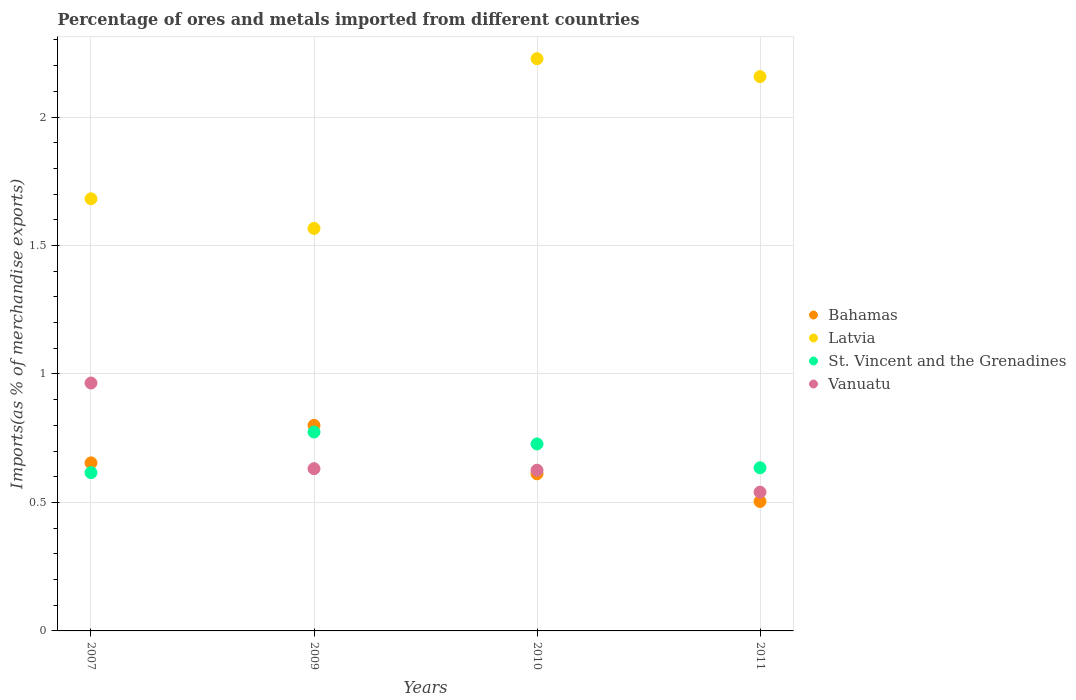Is the number of dotlines equal to the number of legend labels?
Offer a terse response. Yes. What is the percentage of imports to different countries in Vanuatu in 2011?
Make the answer very short. 0.54. Across all years, what is the maximum percentage of imports to different countries in St. Vincent and the Grenadines?
Provide a succinct answer. 0.77. Across all years, what is the minimum percentage of imports to different countries in Vanuatu?
Keep it short and to the point. 0.54. In which year was the percentage of imports to different countries in Vanuatu minimum?
Your answer should be very brief. 2011. What is the total percentage of imports to different countries in Vanuatu in the graph?
Give a very brief answer. 2.76. What is the difference between the percentage of imports to different countries in St. Vincent and the Grenadines in 2010 and that in 2011?
Offer a terse response. 0.09. What is the difference between the percentage of imports to different countries in St. Vincent and the Grenadines in 2010 and the percentage of imports to different countries in Latvia in 2009?
Your answer should be compact. -0.84. What is the average percentage of imports to different countries in Latvia per year?
Provide a short and direct response. 1.91. In the year 2009, what is the difference between the percentage of imports to different countries in Vanuatu and percentage of imports to different countries in Bahamas?
Provide a short and direct response. -0.17. What is the ratio of the percentage of imports to different countries in Vanuatu in 2010 to that in 2011?
Your answer should be very brief. 1.16. Is the difference between the percentage of imports to different countries in Vanuatu in 2009 and 2010 greater than the difference between the percentage of imports to different countries in Bahamas in 2009 and 2010?
Your response must be concise. No. What is the difference between the highest and the second highest percentage of imports to different countries in Vanuatu?
Ensure brevity in your answer.  0.33. What is the difference between the highest and the lowest percentage of imports to different countries in Latvia?
Make the answer very short. 0.66. In how many years, is the percentage of imports to different countries in Bahamas greater than the average percentage of imports to different countries in Bahamas taken over all years?
Ensure brevity in your answer.  2. Is it the case that in every year, the sum of the percentage of imports to different countries in Latvia and percentage of imports to different countries in Bahamas  is greater than the percentage of imports to different countries in St. Vincent and the Grenadines?
Your response must be concise. Yes. Does the percentage of imports to different countries in St. Vincent and the Grenadines monotonically increase over the years?
Make the answer very short. No. Is the percentage of imports to different countries in Vanuatu strictly greater than the percentage of imports to different countries in Latvia over the years?
Your response must be concise. No. Is the percentage of imports to different countries in Vanuatu strictly less than the percentage of imports to different countries in Bahamas over the years?
Offer a terse response. No. How many years are there in the graph?
Keep it short and to the point. 4. Does the graph contain grids?
Your response must be concise. Yes. How many legend labels are there?
Make the answer very short. 4. How are the legend labels stacked?
Give a very brief answer. Vertical. What is the title of the graph?
Offer a terse response. Percentage of ores and metals imported from different countries. Does "Northern Mariana Islands" appear as one of the legend labels in the graph?
Make the answer very short. No. What is the label or title of the Y-axis?
Give a very brief answer. Imports(as % of merchandise exports). What is the Imports(as % of merchandise exports) of Bahamas in 2007?
Ensure brevity in your answer.  0.65. What is the Imports(as % of merchandise exports) in Latvia in 2007?
Provide a short and direct response. 1.68. What is the Imports(as % of merchandise exports) in St. Vincent and the Grenadines in 2007?
Your answer should be compact. 0.62. What is the Imports(as % of merchandise exports) of Vanuatu in 2007?
Offer a very short reply. 0.96. What is the Imports(as % of merchandise exports) of Bahamas in 2009?
Your answer should be compact. 0.8. What is the Imports(as % of merchandise exports) in Latvia in 2009?
Make the answer very short. 1.57. What is the Imports(as % of merchandise exports) in St. Vincent and the Grenadines in 2009?
Offer a terse response. 0.77. What is the Imports(as % of merchandise exports) in Vanuatu in 2009?
Provide a short and direct response. 0.63. What is the Imports(as % of merchandise exports) of Bahamas in 2010?
Offer a terse response. 0.61. What is the Imports(as % of merchandise exports) of Latvia in 2010?
Make the answer very short. 2.23. What is the Imports(as % of merchandise exports) in St. Vincent and the Grenadines in 2010?
Your answer should be very brief. 0.73. What is the Imports(as % of merchandise exports) in Vanuatu in 2010?
Your answer should be compact. 0.63. What is the Imports(as % of merchandise exports) in Bahamas in 2011?
Offer a terse response. 0.5. What is the Imports(as % of merchandise exports) of Latvia in 2011?
Offer a very short reply. 2.16. What is the Imports(as % of merchandise exports) of St. Vincent and the Grenadines in 2011?
Your response must be concise. 0.64. What is the Imports(as % of merchandise exports) of Vanuatu in 2011?
Your answer should be very brief. 0.54. Across all years, what is the maximum Imports(as % of merchandise exports) in Bahamas?
Make the answer very short. 0.8. Across all years, what is the maximum Imports(as % of merchandise exports) in Latvia?
Make the answer very short. 2.23. Across all years, what is the maximum Imports(as % of merchandise exports) of St. Vincent and the Grenadines?
Your response must be concise. 0.77. Across all years, what is the maximum Imports(as % of merchandise exports) of Vanuatu?
Offer a very short reply. 0.96. Across all years, what is the minimum Imports(as % of merchandise exports) of Bahamas?
Offer a terse response. 0.5. Across all years, what is the minimum Imports(as % of merchandise exports) in Latvia?
Offer a very short reply. 1.57. Across all years, what is the minimum Imports(as % of merchandise exports) in St. Vincent and the Grenadines?
Keep it short and to the point. 0.62. Across all years, what is the minimum Imports(as % of merchandise exports) of Vanuatu?
Provide a succinct answer. 0.54. What is the total Imports(as % of merchandise exports) in Bahamas in the graph?
Give a very brief answer. 2.57. What is the total Imports(as % of merchandise exports) of Latvia in the graph?
Your answer should be compact. 7.63. What is the total Imports(as % of merchandise exports) in St. Vincent and the Grenadines in the graph?
Your answer should be compact. 2.75. What is the total Imports(as % of merchandise exports) in Vanuatu in the graph?
Your answer should be very brief. 2.76. What is the difference between the Imports(as % of merchandise exports) in Bahamas in 2007 and that in 2009?
Provide a succinct answer. -0.15. What is the difference between the Imports(as % of merchandise exports) of Latvia in 2007 and that in 2009?
Your answer should be very brief. 0.12. What is the difference between the Imports(as % of merchandise exports) in St. Vincent and the Grenadines in 2007 and that in 2009?
Provide a succinct answer. -0.16. What is the difference between the Imports(as % of merchandise exports) of Vanuatu in 2007 and that in 2009?
Your response must be concise. 0.33. What is the difference between the Imports(as % of merchandise exports) in Bahamas in 2007 and that in 2010?
Your answer should be compact. 0.04. What is the difference between the Imports(as % of merchandise exports) in Latvia in 2007 and that in 2010?
Provide a short and direct response. -0.55. What is the difference between the Imports(as % of merchandise exports) of St. Vincent and the Grenadines in 2007 and that in 2010?
Your answer should be compact. -0.11. What is the difference between the Imports(as % of merchandise exports) in Vanuatu in 2007 and that in 2010?
Make the answer very short. 0.34. What is the difference between the Imports(as % of merchandise exports) of Bahamas in 2007 and that in 2011?
Provide a succinct answer. 0.15. What is the difference between the Imports(as % of merchandise exports) of Latvia in 2007 and that in 2011?
Offer a terse response. -0.48. What is the difference between the Imports(as % of merchandise exports) of St. Vincent and the Grenadines in 2007 and that in 2011?
Your response must be concise. -0.02. What is the difference between the Imports(as % of merchandise exports) in Vanuatu in 2007 and that in 2011?
Your answer should be compact. 0.42. What is the difference between the Imports(as % of merchandise exports) in Bahamas in 2009 and that in 2010?
Make the answer very short. 0.19. What is the difference between the Imports(as % of merchandise exports) in Latvia in 2009 and that in 2010?
Your response must be concise. -0.66. What is the difference between the Imports(as % of merchandise exports) in St. Vincent and the Grenadines in 2009 and that in 2010?
Offer a terse response. 0.05. What is the difference between the Imports(as % of merchandise exports) of Vanuatu in 2009 and that in 2010?
Make the answer very short. 0.01. What is the difference between the Imports(as % of merchandise exports) in Bahamas in 2009 and that in 2011?
Give a very brief answer. 0.3. What is the difference between the Imports(as % of merchandise exports) in Latvia in 2009 and that in 2011?
Make the answer very short. -0.59. What is the difference between the Imports(as % of merchandise exports) in St. Vincent and the Grenadines in 2009 and that in 2011?
Ensure brevity in your answer.  0.14. What is the difference between the Imports(as % of merchandise exports) of Vanuatu in 2009 and that in 2011?
Keep it short and to the point. 0.09. What is the difference between the Imports(as % of merchandise exports) in Bahamas in 2010 and that in 2011?
Your answer should be compact. 0.11. What is the difference between the Imports(as % of merchandise exports) of Latvia in 2010 and that in 2011?
Provide a succinct answer. 0.07. What is the difference between the Imports(as % of merchandise exports) of St. Vincent and the Grenadines in 2010 and that in 2011?
Offer a very short reply. 0.09. What is the difference between the Imports(as % of merchandise exports) in Vanuatu in 2010 and that in 2011?
Offer a terse response. 0.09. What is the difference between the Imports(as % of merchandise exports) in Bahamas in 2007 and the Imports(as % of merchandise exports) in Latvia in 2009?
Keep it short and to the point. -0.91. What is the difference between the Imports(as % of merchandise exports) of Bahamas in 2007 and the Imports(as % of merchandise exports) of St. Vincent and the Grenadines in 2009?
Your answer should be compact. -0.12. What is the difference between the Imports(as % of merchandise exports) of Bahamas in 2007 and the Imports(as % of merchandise exports) of Vanuatu in 2009?
Provide a short and direct response. 0.02. What is the difference between the Imports(as % of merchandise exports) in Latvia in 2007 and the Imports(as % of merchandise exports) in St. Vincent and the Grenadines in 2009?
Your answer should be very brief. 0.91. What is the difference between the Imports(as % of merchandise exports) of Latvia in 2007 and the Imports(as % of merchandise exports) of Vanuatu in 2009?
Offer a very short reply. 1.05. What is the difference between the Imports(as % of merchandise exports) in St. Vincent and the Grenadines in 2007 and the Imports(as % of merchandise exports) in Vanuatu in 2009?
Ensure brevity in your answer.  -0.02. What is the difference between the Imports(as % of merchandise exports) of Bahamas in 2007 and the Imports(as % of merchandise exports) of Latvia in 2010?
Offer a terse response. -1.57. What is the difference between the Imports(as % of merchandise exports) in Bahamas in 2007 and the Imports(as % of merchandise exports) in St. Vincent and the Grenadines in 2010?
Your answer should be very brief. -0.07. What is the difference between the Imports(as % of merchandise exports) in Bahamas in 2007 and the Imports(as % of merchandise exports) in Vanuatu in 2010?
Your answer should be compact. 0.03. What is the difference between the Imports(as % of merchandise exports) of Latvia in 2007 and the Imports(as % of merchandise exports) of St. Vincent and the Grenadines in 2010?
Keep it short and to the point. 0.95. What is the difference between the Imports(as % of merchandise exports) of Latvia in 2007 and the Imports(as % of merchandise exports) of Vanuatu in 2010?
Your answer should be very brief. 1.06. What is the difference between the Imports(as % of merchandise exports) of St. Vincent and the Grenadines in 2007 and the Imports(as % of merchandise exports) of Vanuatu in 2010?
Offer a terse response. -0.01. What is the difference between the Imports(as % of merchandise exports) of Bahamas in 2007 and the Imports(as % of merchandise exports) of Latvia in 2011?
Keep it short and to the point. -1.5. What is the difference between the Imports(as % of merchandise exports) of Bahamas in 2007 and the Imports(as % of merchandise exports) of St. Vincent and the Grenadines in 2011?
Your answer should be compact. 0.02. What is the difference between the Imports(as % of merchandise exports) of Bahamas in 2007 and the Imports(as % of merchandise exports) of Vanuatu in 2011?
Keep it short and to the point. 0.11. What is the difference between the Imports(as % of merchandise exports) of Latvia in 2007 and the Imports(as % of merchandise exports) of St. Vincent and the Grenadines in 2011?
Ensure brevity in your answer.  1.05. What is the difference between the Imports(as % of merchandise exports) of Latvia in 2007 and the Imports(as % of merchandise exports) of Vanuatu in 2011?
Ensure brevity in your answer.  1.14. What is the difference between the Imports(as % of merchandise exports) in St. Vincent and the Grenadines in 2007 and the Imports(as % of merchandise exports) in Vanuatu in 2011?
Keep it short and to the point. 0.08. What is the difference between the Imports(as % of merchandise exports) of Bahamas in 2009 and the Imports(as % of merchandise exports) of Latvia in 2010?
Provide a short and direct response. -1.43. What is the difference between the Imports(as % of merchandise exports) of Bahamas in 2009 and the Imports(as % of merchandise exports) of St. Vincent and the Grenadines in 2010?
Give a very brief answer. 0.07. What is the difference between the Imports(as % of merchandise exports) in Bahamas in 2009 and the Imports(as % of merchandise exports) in Vanuatu in 2010?
Offer a very short reply. 0.17. What is the difference between the Imports(as % of merchandise exports) of Latvia in 2009 and the Imports(as % of merchandise exports) of St. Vincent and the Grenadines in 2010?
Provide a succinct answer. 0.84. What is the difference between the Imports(as % of merchandise exports) of Latvia in 2009 and the Imports(as % of merchandise exports) of Vanuatu in 2010?
Your response must be concise. 0.94. What is the difference between the Imports(as % of merchandise exports) in St. Vincent and the Grenadines in 2009 and the Imports(as % of merchandise exports) in Vanuatu in 2010?
Give a very brief answer. 0.15. What is the difference between the Imports(as % of merchandise exports) in Bahamas in 2009 and the Imports(as % of merchandise exports) in Latvia in 2011?
Provide a short and direct response. -1.36. What is the difference between the Imports(as % of merchandise exports) in Bahamas in 2009 and the Imports(as % of merchandise exports) in St. Vincent and the Grenadines in 2011?
Offer a very short reply. 0.17. What is the difference between the Imports(as % of merchandise exports) of Bahamas in 2009 and the Imports(as % of merchandise exports) of Vanuatu in 2011?
Give a very brief answer. 0.26. What is the difference between the Imports(as % of merchandise exports) in Latvia in 2009 and the Imports(as % of merchandise exports) in St. Vincent and the Grenadines in 2011?
Offer a very short reply. 0.93. What is the difference between the Imports(as % of merchandise exports) in Latvia in 2009 and the Imports(as % of merchandise exports) in Vanuatu in 2011?
Provide a succinct answer. 1.03. What is the difference between the Imports(as % of merchandise exports) of St. Vincent and the Grenadines in 2009 and the Imports(as % of merchandise exports) of Vanuatu in 2011?
Your answer should be compact. 0.23. What is the difference between the Imports(as % of merchandise exports) of Bahamas in 2010 and the Imports(as % of merchandise exports) of Latvia in 2011?
Your answer should be compact. -1.55. What is the difference between the Imports(as % of merchandise exports) in Bahamas in 2010 and the Imports(as % of merchandise exports) in St. Vincent and the Grenadines in 2011?
Your answer should be compact. -0.02. What is the difference between the Imports(as % of merchandise exports) in Bahamas in 2010 and the Imports(as % of merchandise exports) in Vanuatu in 2011?
Offer a terse response. 0.07. What is the difference between the Imports(as % of merchandise exports) of Latvia in 2010 and the Imports(as % of merchandise exports) of St. Vincent and the Grenadines in 2011?
Your response must be concise. 1.59. What is the difference between the Imports(as % of merchandise exports) of Latvia in 2010 and the Imports(as % of merchandise exports) of Vanuatu in 2011?
Your answer should be very brief. 1.69. What is the difference between the Imports(as % of merchandise exports) in St. Vincent and the Grenadines in 2010 and the Imports(as % of merchandise exports) in Vanuatu in 2011?
Your answer should be very brief. 0.19. What is the average Imports(as % of merchandise exports) in Bahamas per year?
Give a very brief answer. 0.64. What is the average Imports(as % of merchandise exports) of Latvia per year?
Provide a succinct answer. 1.91. What is the average Imports(as % of merchandise exports) in St. Vincent and the Grenadines per year?
Your answer should be compact. 0.69. What is the average Imports(as % of merchandise exports) in Vanuatu per year?
Ensure brevity in your answer.  0.69. In the year 2007, what is the difference between the Imports(as % of merchandise exports) of Bahamas and Imports(as % of merchandise exports) of Latvia?
Give a very brief answer. -1.03. In the year 2007, what is the difference between the Imports(as % of merchandise exports) in Bahamas and Imports(as % of merchandise exports) in St. Vincent and the Grenadines?
Offer a terse response. 0.04. In the year 2007, what is the difference between the Imports(as % of merchandise exports) in Bahamas and Imports(as % of merchandise exports) in Vanuatu?
Keep it short and to the point. -0.31. In the year 2007, what is the difference between the Imports(as % of merchandise exports) of Latvia and Imports(as % of merchandise exports) of St. Vincent and the Grenadines?
Keep it short and to the point. 1.07. In the year 2007, what is the difference between the Imports(as % of merchandise exports) of Latvia and Imports(as % of merchandise exports) of Vanuatu?
Offer a very short reply. 0.72. In the year 2007, what is the difference between the Imports(as % of merchandise exports) of St. Vincent and the Grenadines and Imports(as % of merchandise exports) of Vanuatu?
Make the answer very short. -0.35. In the year 2009, what is the difference between the Imports(as % of merchandise exports) in Bahamas and Imports(as % of merchandise exports) in Latvia?
Your response must be concise. -0.77. In the year 2009, what is the difference between the Imports(as % of merchandise exports) of Bahamas and Imports(as % of merchandise exports) of St. Vincent and the Grenadines?
Provide a short and direct response. 0.03. In the year 2009, what is the difference between the Imports(as % of merchandise exports) in Bahamas and Imports(as % of merchandise exports) in Vanuatu?
Your answer should be very brief. 0.17. In the year 2009, what is the difference between the Imports(as % of merchandise exports) in Latvia and Imports(as % of merchandise exports) in St. Vincent and the Grenadines?
Provide a succinct answer. 0.79. In the year 2009, what is the difference between the Imports(as % of merchandise exports) in Latvia and Imports(as % of merchandise exports) in Vanuatu?
Provide a succinct answer. 0.94. In the year 2009, what is the difference between the Imports(as % of merchandise exports) of St. Vincent and the Grenadines and Imports(as % of merchandise exports) of Vanuatu?
Provide a short and direct response. 0.14. In the year 2010, what is the difference between the Imports(as % of merchandise exports) of Bahamas and Imports(as % of merchandise exports) of Latvia?
Give a very brief answer. -1.62. In the year 2010, what is the difference between the Imports(as % of merchandise exports) in Bahamas and Imports(as % of merchandise exports) in St. Vincent and the Grenadines?
Offer a very short reply. -0.12. In the year 2010, what is the difference between the Imports(as % of merchandise exports) of Bahamas and Imports(as % of merchandise exports) of Vanuatu?
Make the answer very short. -0.01. In the year 2010, what is the difference between the Imports(as % of merchandise exports) in Latvia and Imports(as % of merchandise exports) in St. Vincent and the Grenadines?
Your answer should be very brief. 1.5. In the year 2010, what is the difference between the Imports(as % of merchandise exports) of Latvia and Imports(as % of merchandise exports) of Vanuatu?
Your response must be concise. 1.6. In the year 2010, what is the difference between the Imports(as % of merchandise exports) in St. Vincent and the Grenadines and Imports(as % of merchandise exports) in Vanuatu?
Provide a short and direct response. 0.1. In the year 2011, what is the difference between the Imports(as % of merchandise exports) of Bahamas and Imports(as % of merchandise exports) of Latvia?
Provide a succinct answer. -1.65. In the year 2011, what is the difference between the Imports(as % of merchandise exports) of Bahamas and Imports(as % of merchandise exports) of St. Vincent and the Grenadines?
Make the answer very short. -0.13. In the year 2011, what is the difference between the Imports(as % of merchandise exports) of Bahamas and Imports(as % of merchandise exports) of Vanuatu?
Your answer should be compact. -0.04. In the year 2011, what is the difference between the Imports(as % of merchandise exports) of Latvia and Imports(as % of merchandise exports) of St. Vincent and the Grenadines?
Make the answer very short. 1.52. In the year 2011, what is the difference between the Imports(as % of merchandise exports) of Latvia and Imports(as % of merchandise exports) of Vanuatu?
Keep it short and to the point. 1.62. In the year 2011, what is the difference between the Imports(as % of merchandise exports) in St. Vincent and the Grenadines and Imports(as % of merchandise exports) in Vanuatu?
Offer a terse response. 0.09. What is the ratio of the Imports(as % of merchandise exports) in Bahamas in 2007 to that in 2009?
Give a very brief answer. 0.82. What is the ratio of the Imports(as % of merchandise exports) of Latvia in 2007 to that in 2009?
Your answer should be very brief. 1.07. What is the ratio of the Imports(as % of merchandise exports) in St. Vincent and the Grenadines in 2007 to that in 2009?
Your response must be concise. 0.8. What is the ratio of the Imports(as % of merchandise exports) in Vanuatu in 2007 to that in 2009?
Give a very brief answer. 1.53. What is the ratio of the Imports(as % of merchandise exports) in Bahamas in 2007 to that in 2010?
Offer a terse response. 1.07. What is the ratio of the Imports(as % of merchandise exports) of Latvia in 2007 to that in 2010?
Keep it short and to the point. 0.76. What is the ratio of the Imports(as % of merchandise exports) in St. Vincent and the Grenadines in 2007 to that in 2010?
Offer a very short reply. 0.85. What is the ratio of the Imports(as % of merchandise exports) in Vanuatu in 2007 to that in 2010?
Provide a succinct answer. 1.54. What is the ratio of the Imports(as % of merchandise exports) of Bahamas in 2007 to that in 2011?
Provide a short and direct response. 1.3. What is the ratio of the Imports(as % of merchandise exports) of Latvia in 2007 to that in 2011?
Give a very brief answer. 0.78. What is the ratio of the Imports(as % of merchandise exports) in St. Vincent and the Grenadines in 2007 to that in 2011?
Provide a succinct answer. 0.97. What is the ratio of the Imports(as % of merchandise exports) in Vanuatu in 2007 to that in 2011?
Offer a terse response. 1.79. What is the ratio of the Imports(as % of merchandise exports) of Bahamas in 2009 to that in 2010?
Offer a terse response. 1.31. What is the ratio of the Imports(as % of merchandise exports) in Latvia in 2009 to that in 2010?
Give a very brief answer. 0.7. What is the ratio of the Imports(as % of merchandise exports) in St. Vincent and the Grenadines in 2009 to that in 2010?
Keep it short and to the point. 1.06. What is the ratio of the Imports(as % of merchandise exports) in Vanuatu in 2009 to that in 2010?
Provide a short and direct response. 1.01. What is the ratio of the Imports(as % of merchandise exports) of Bahamas in 2009 to that in 2011?
Your answer should be compact. 1.59. What is the ratio of the Imports(as % of merchandise exports) of Latvia in 2009 to that in 2011?
Your answer should be very brief. 0.73. What is the ratio of the Imports(as % of merchandise exports) in St. Vincent and the Grenadines in 2009 to that in 2011?
Make the answer very short. 1.22. What is the ratio of the Imports(as % of merchandise exports) in Vanuatu in 2009 to that in 2011?
Provide a succinct answer. 1.17. What is the ratio of the Imports(as % of merchandise exports) in Bahamas in 2010 to that in 2011?
Offer a very short reply. 1.21. What is the ratio of the Imports(as % of merchandise exports) in Latvia in 2010 to that in 2011?
Your answer should be very brief. 1.03. What is the ratio of the Imports(as % of merchandise exports) of St. Vincent and the Grenadines in 2010 to that in 2011?
Offer a terse response. 1.15. What is the ratio of the Imports(as % of merchandise exports) in Vanuatu in 2010 to that in 2011?
Your response must be concise. 1.16. What is the difference between the highest and the second highest Imports(as % of merchandise exports) in Bahamas?
Ensure brevity in your answer.  0.15. What is the difference between the highest and the second highest Imports(as % of merchandise exports) of Latvia?
Your answer should be compact. 0.07. What is the difference between the highest and the second highest Imports(as % of merchandise exports) in St. Vincent and the Grenadines?
Keep it short and to the point. 0.05. What is the difference between the highest and the second highest Imports(as % of merchandise exports) of Vanuatu?
Provide a short and direct response. 0.33. What is the difference between the highest and the lowest Imports(as % of merchandise exports) of Bahamas?
Offer a terse response. 0.3. What is the difference between the highest and the lowest Imports(as % of merchandise exports) of Latvia?
Ensure brevity in your answer.  0.66. What is the difference between the highest and the lowest Imports(as % of merchandise exports) in St. Vincent and the Grenadines?
Your response must be concise. 0.16. What is the difference between the highest and the lowest Imports(as % of merchandise exports) of Vanuatu?
Offer a terse response. 0.42. 